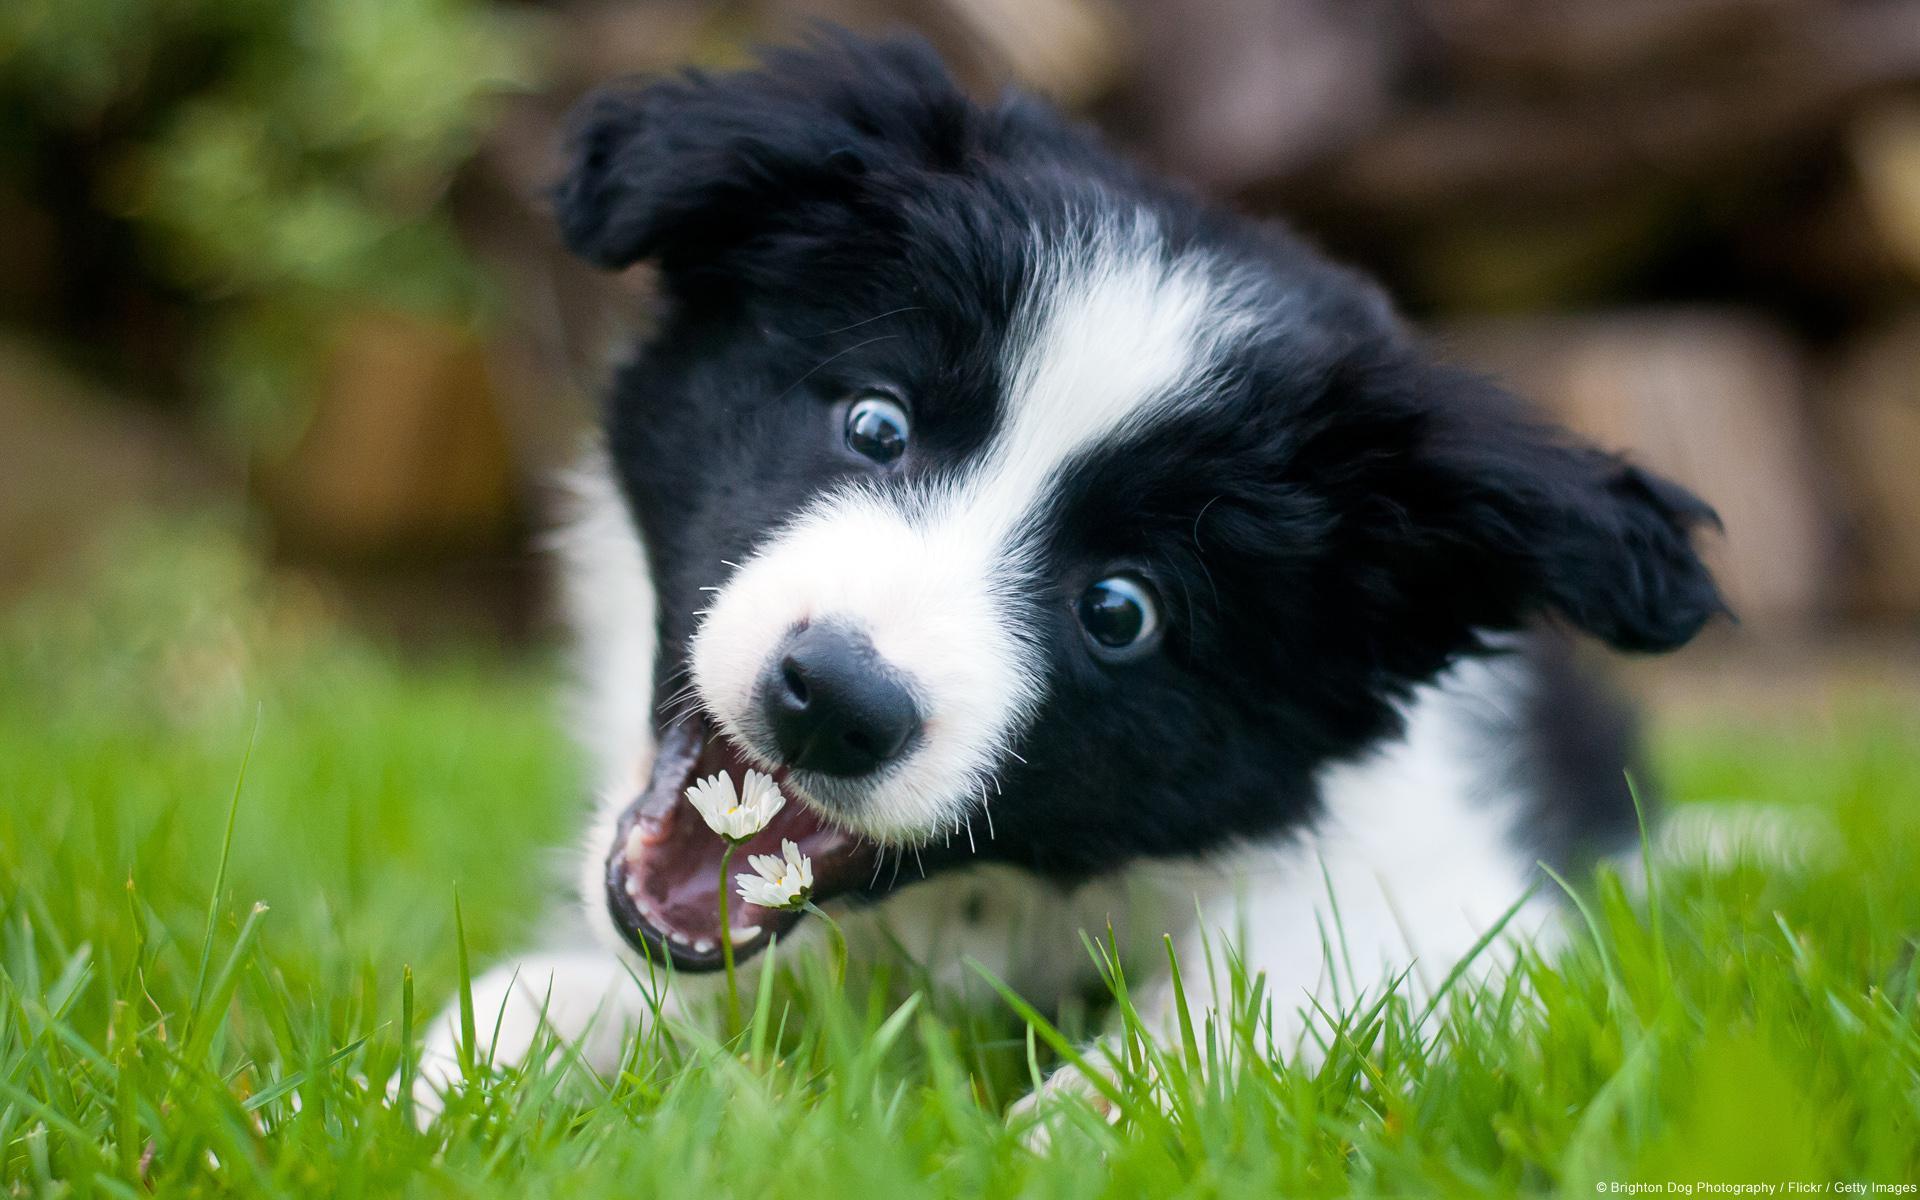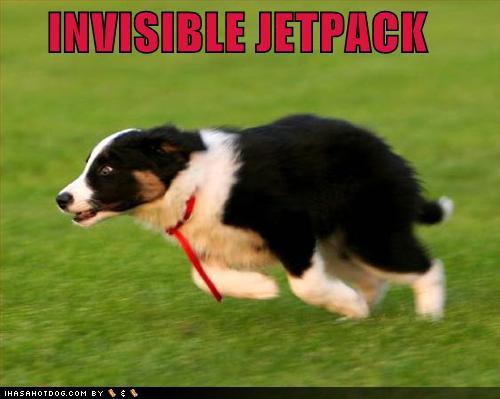The first image is the image on the left, the second image is the image on the right. Considering the images on both sides, is "An image shows a dog reclining on the grass with its head cocked at a sharp angle." valid? Answer yes or no. Yes. The first image is the image on the left, the second image is the image on the right. Analyze the images presented: Is the assertion "The dog in one of the images has its head tilted to the side." valid? Answer yes or no. Yes. 